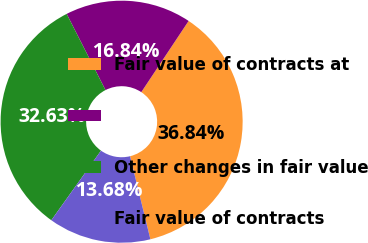Convert chart. <chart><loc_0><loc_0><loc_500><loc_500><pie_chart><fcel>Fair value of contracts at<fcel>Unnamed: 1<fcel>Other changes in fair value<fcel>Fair value of contracts<nl><fcel>36.84%<fcel>16.84%<fcel>32.63%<fcel>13.68%<nl></chart> 